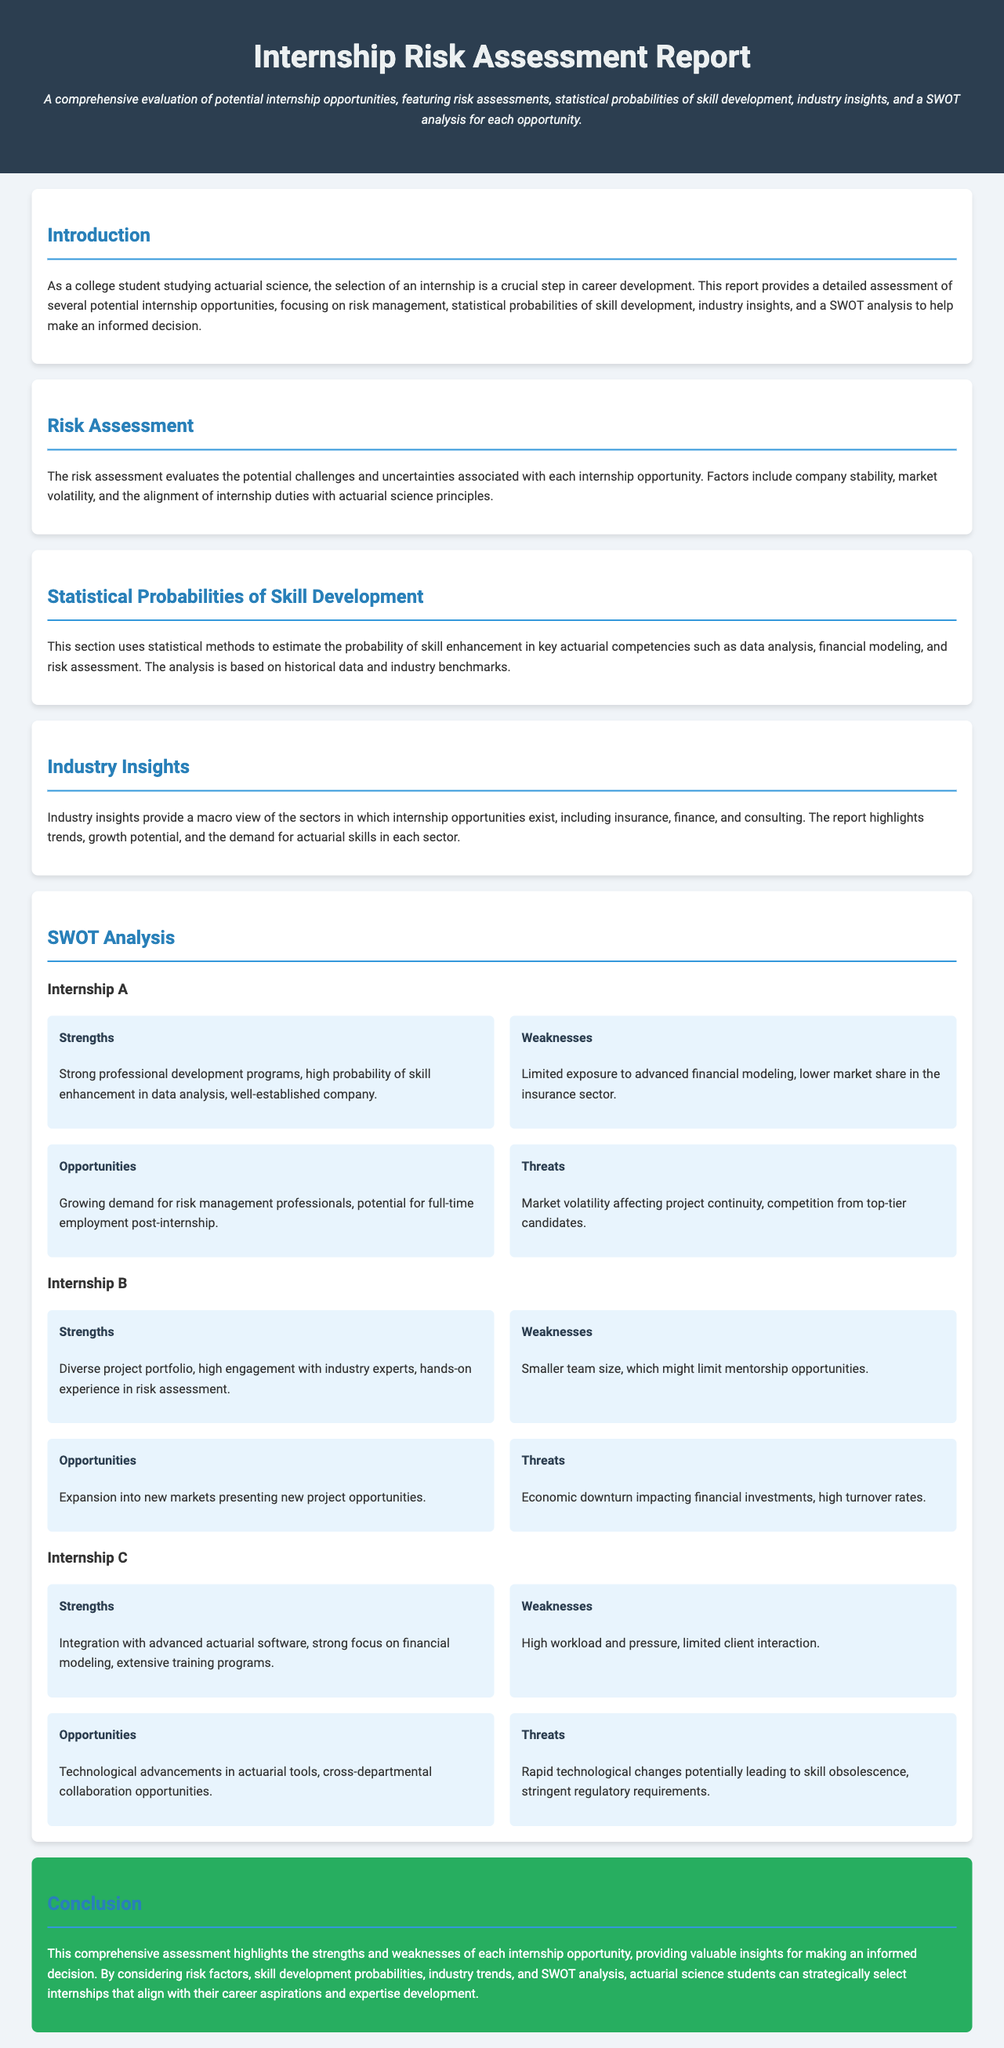what is the main focus of the report? The report's main focus is a comprehensive evaluation of potential internship opportunities, with risk assessments and industry insights.
Answer: internship opportunities what section discusses the alignment of internship duties with actuarial principles? The section that evaluates potential challenges and uncertainties associated with each internship opportunity discusses the alignment of internship duties with actuarial science principles.
Answer: Risk Assessment what are the strengths of Internship A? The strengths of Internship A include strong professional development programs and a high probability of skill enhancement in data analysis.
Answer: Strong professional development programs what is a weakness of Internship B? A weakness of Internship B is its smaller team size, which might limit mentorship opportunities.
Answer: Smaller team size which industry insights does the report provide? The report provides insights into the insurance, finance, and consulting sectors, highlighting trends and growth potential.
Answer: insurance, finance, consulting what is the potential opportunity mentioned for Internship C? The report states that opportunities include technological advancements in actuarial tools and cross-departmental collaboration.
Answer: Technological advancements who is the intended audience for this report? The intended audience is college students studying actuarial science.
Answer: college students what is the conclusion of the report? The conclusion highlights the strengths and weaknesses of each internship and provides insights for strategic selection.
Answer: strengths and weaknesses of each internship 